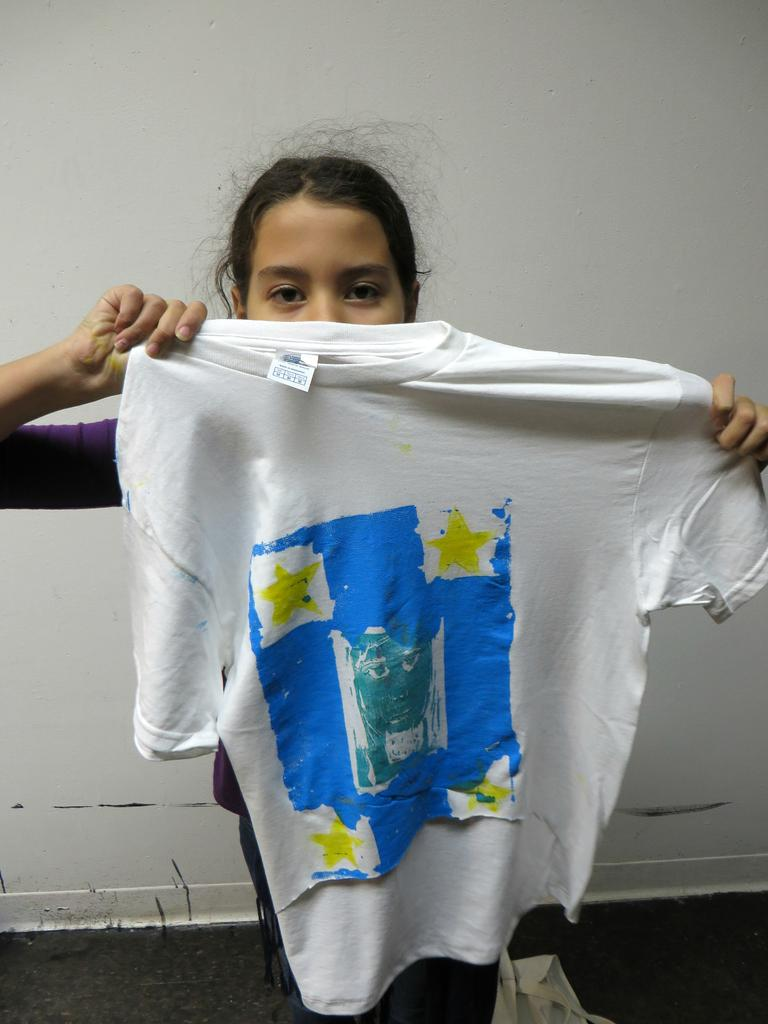Where was the image taken? The image was taken inside a room. What is the girl doing in the image? The girl is standing in the middle of the image and holding a t-shirt in her hand. What can be seen in the background of the image? There is a wall visible in the background of the image. What news is the girl reacting to in the image? There is no indication of any news or reaction in the image; the girl is simply standing and holding a t-shirt. 